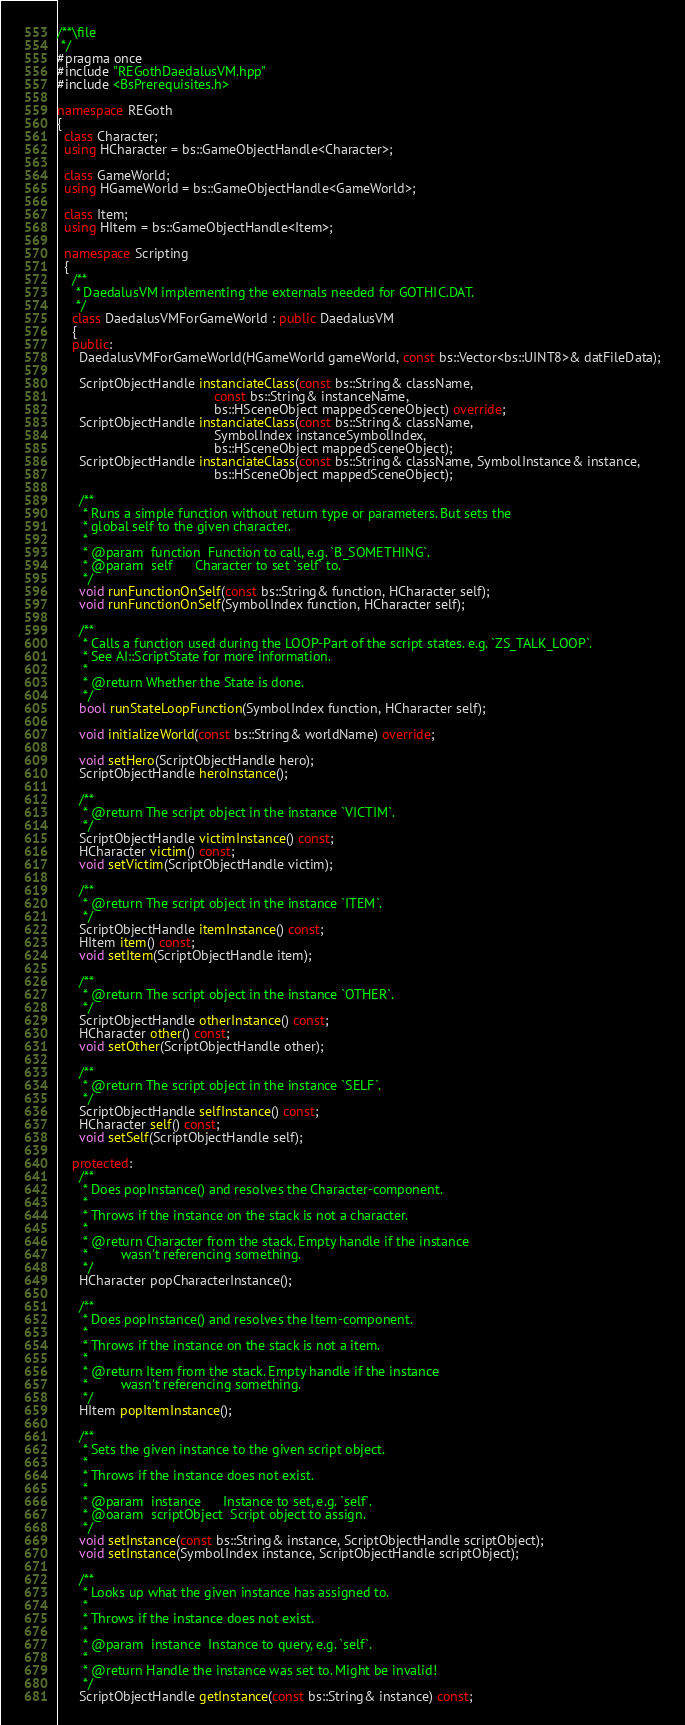Convert code to text. <code><loc_0><loc_0><loc_500><loc_500><_C++_>/**\file
 */
#pragma once
#include "REGothDaedalusVM.hpp"
#include <BsPrerequisites.h>

namespace REGoth
{
  class Character;
  using HCharacter = bs::GameObjectHandle<Character>;

  class GameWorld;
  using HGameWorld = bs::GameObjectHandle<GameWorld>;

  class Item;
  using HItem = bs::GameObjectHandle<Item>;

  namespace Scripting
  {
    /**
     * DaedalusVM implementing the externals needed for GOTHIC.DAT.
     */
    class DaedalusVMForGameWorld : public DaedalusVM
    {
    public:
      DaedalusVMForGameWorld(HGameWorld gameWorld, const bs::Vector<bs::UINT8>& datFileData);

      ScriptObjectHandle instanciateClass(const bs::String& className,
                                          const bs::String& instanceName,
                                          bs::HSceneObject mappedSceneObject) override;
      ScriptObjectHandle instanciateClass(const bs::String& className,
                                          SymbolIndex instanceSymbolIndex,
                                          bs::HSceneObject mappedSceneObject);
      ScriptObjectHandle instanciateClass(const bs::String& className, SymbolInstance& instance,
                                          bs::HSceneObject mappedSceneObject);

      /**
       * Runs a simple function without return type or parameters. But sets the
       * global self to the given character.
       *
       * @param  function  Function to call, e.g. `B_SOMETHING`.
       * @param  self      Character to set `self` to.
       */
      void runFunctionOnSelf(const bs::String& function, HCharacter self);
      void runFunctionOnSelf(SymbolIndex function, HCharacter self);

      /**
       * Calls a function used during the LOOP-Part of the script states. e.g. `ZS_TALK_LOOP`.
       * See AI::ScriptState for more information.
       *
       * @return Whether the State is done.
       */
      bool runStateLoopFunction(SymbolIndex function, HCharacter self);

      void initializeWorld(const bs::String& worldName) override;

      void setHero(ScriptObjectHandle hero);
      ScriptObjectHandle heroInstance();

      /**
       * @return The script object in the instance `VICTIM`.
       */
      ScriptObjectHandle victimInstance() const;
      HCharacter victim() const;
      void setVictim(ScriptObjectHandle victim);

      /**
       * @return The script object in the instance `ITEM`.
       */
      ScriptObjectHandle itemInstance() const;
      HItem item() const;
      void setItem(ScriptObjectHandle item);

      /**
       * @return The script object in the instance `OTHER`.
       */
      ScriptObjectHandle otherInstance() const;
      HCharacter other() const;
      void setOther(ScriptObjectHandle other);

      /**
       * @return The script object in the instance `SELF`.
       */
      ScriptObjectHandle selfInstance() const;
      HCharacter self() const;
      void setSelf(ScriptObjectHandle self);

    protected:
      /**
       * Does popInstance() and resolves the Character-component.
       *
       * Throws if the instance on the stack is not a character.
       *
       * @return Character from the stack. Empty handle if the instance
       *         wasn't referencing something.
       */
      HCharacter popCharacterInstance();

      /**
       * Does popInstance() and resolves the Item-component.
       *
       * Throws if the instance on the stack is not a item.
       *
       * @return Item from the stack. Empty handle if the instance
       *         wasn't referencing something.
       */
      HItem popItemInstance();

      /**
       * Sets the given instance to the given script object.
       *
       * Throws if the instance does not exist.
       *
       * @param  instance      Instance to set, e.g. `self`.
       * @oaram  scriptObject  Script object to assign.
       */
      void setInstance(const bs::String& instance, ScriptObjectHandle scriptObject);
      void setInstance(SymbolIndex instance, ScriptObjectHandle scriptObject);

      /**
       * Looks up what the given instance has assigned to.
       *
       * Throws if the instance does not exist.
       *
       * @param  instance  Instance to query, e.g. `self`.
       *
       * @return Handle the instance was set to. Might be invalid!
       */
      ScriptObjectHandle getInstance(const bs::String& instance) const;</code> 